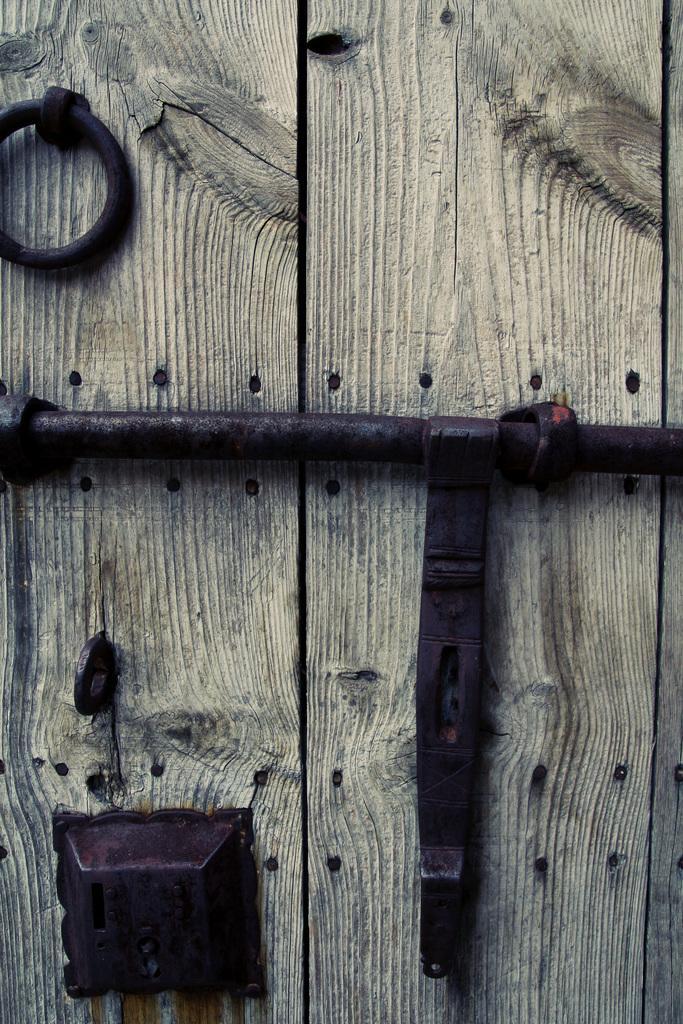How would you summarize this image in a sentence or two? In this picture, we see the wooden door. At the bottom, we see the door lock on the wooden door. In the middle of the picture, we see a door hasp, which is in black color. 